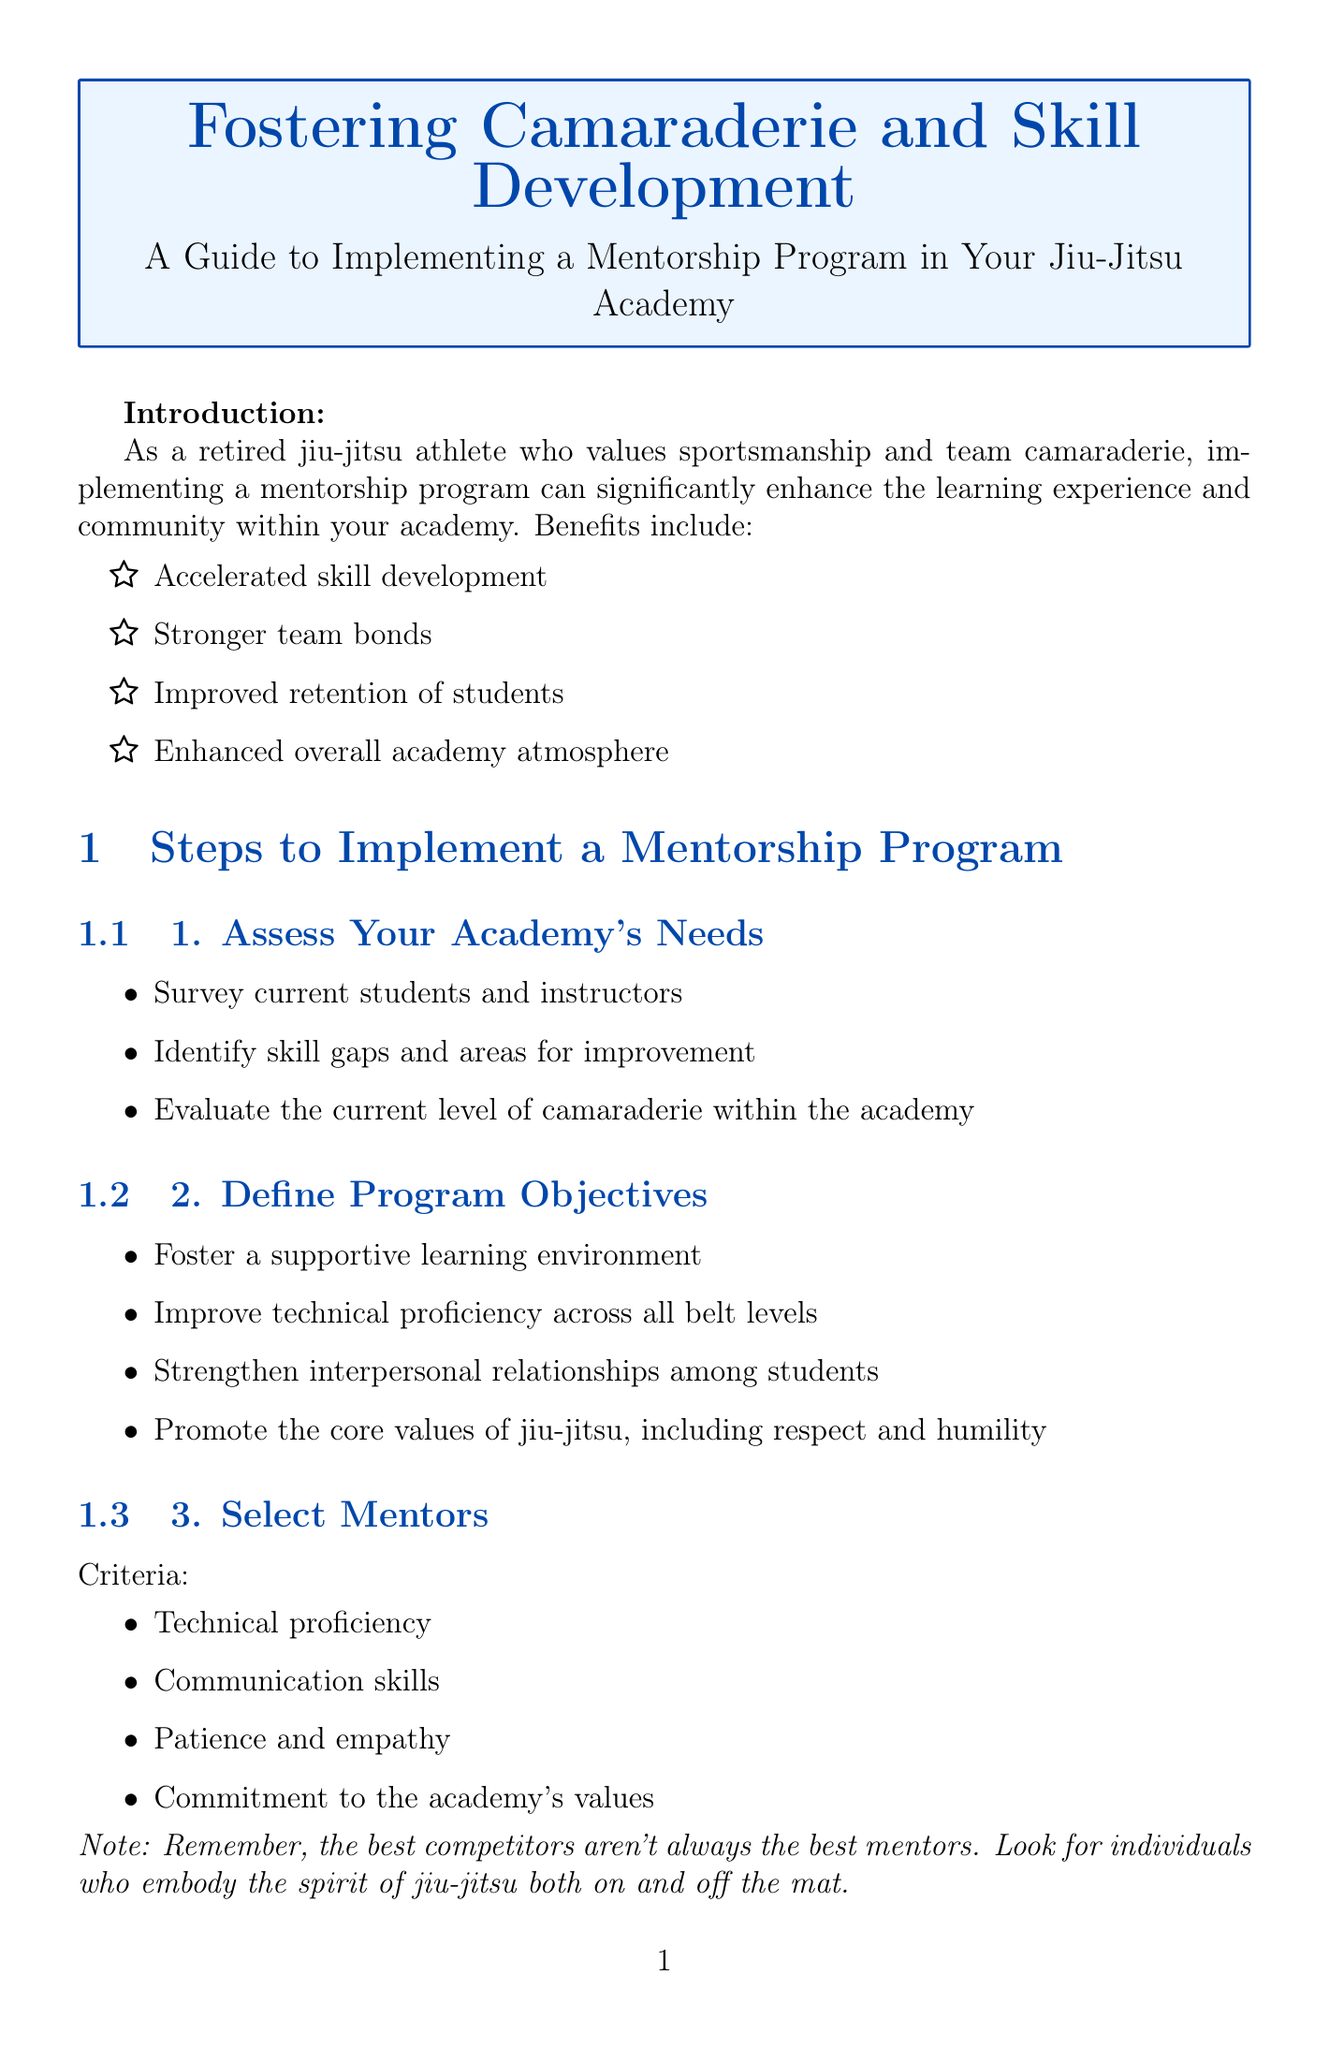1. What is the main goal of the mentorship program? The main goal is to enhance the learning experience and community within the academy.
Answer: Enhance learning experience and community 2. How many steps are there to implement the mentorship program? The number of steps is explicitly stated in the document.
Answer: Ten steps 3. What is one benefit of implementing a mentorship program? The document lists several benefits, and one of them can be extracted directly.
Answer: Accelerated skill development 4. What criteria should be used to select mentors? The document mentions specific criteria for selecting mentors.
Answer: Technical proficiency 5. Name one type of team-building activity suggested in the document. The document provides examples of team-building activities, and one can be cited directly.
Answer: Monthly team dinners 6. What is the purpose of the 'Most Improved' awards? The document states this recognition system's intention.
Answer: Recognition of improvement 7. How often should feedback surveys for the mentorship program be conducted? The document specifies the frequency of these feedback surveys.
Answer: Regularly 8. What should be included in the structured program? One of the components for the structured program can be directly referenced.
Answer: Regular one-on-one training sessions 9. What is a strategy for continuously improving the mentorship program? The document suggests several strategies, and one can be mentioned directly.
Answer: Stay updated on mentorship best practices 10. What is the concluding message of the guide? The document includes a concluding message that encapsulates its main theme.
Answer: Create a jiu-jitsu academy that fosters a tight-knit community 